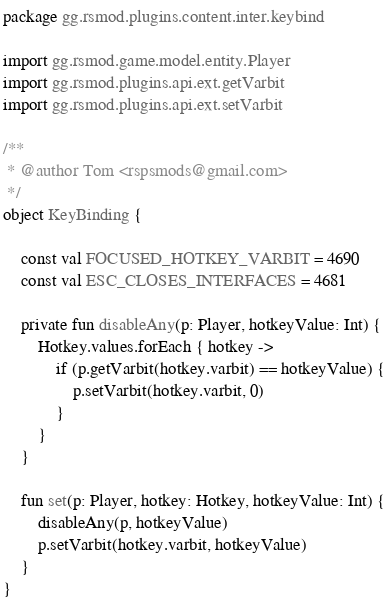Convert code to text. <code><loc_0><loc_0><loc_500><loc_500><_Kotlin_>package gg.rsmod.plugins.content.inter.keybind

import gg.rsmod.game.model.entity.Player
import gg.rsmod.plugins.api.ext.getVarbit
import gg.rsmod.plugins.api.ext.setVarbit

/**
 * @author Tom <rspsmods@gmail.com>
 */
object KeyBinding {

    const val FOCUSED_HOTKEY_VARBIT = 4690
    const val ESC_CLOSES_INTERFACES = 4681

    private fun disableAny(p: Player, hotkeyValue: Int) {
        Hotkey.values.forEach { hotkey ->
            if (p.getVarbit(hotkey.varbit) == hotkeyValue) {
                p.setVarbit(hotkey.varbit, 0)
            }
        }
    }

    fun set(p: Player, hotkey: Hotkey, hotkeyValue: Int) {
        disableAny(p, hotkeyValue)
        p.setVarbit(hotkey.varbit, hotkeyValue)
    }
}</code> 